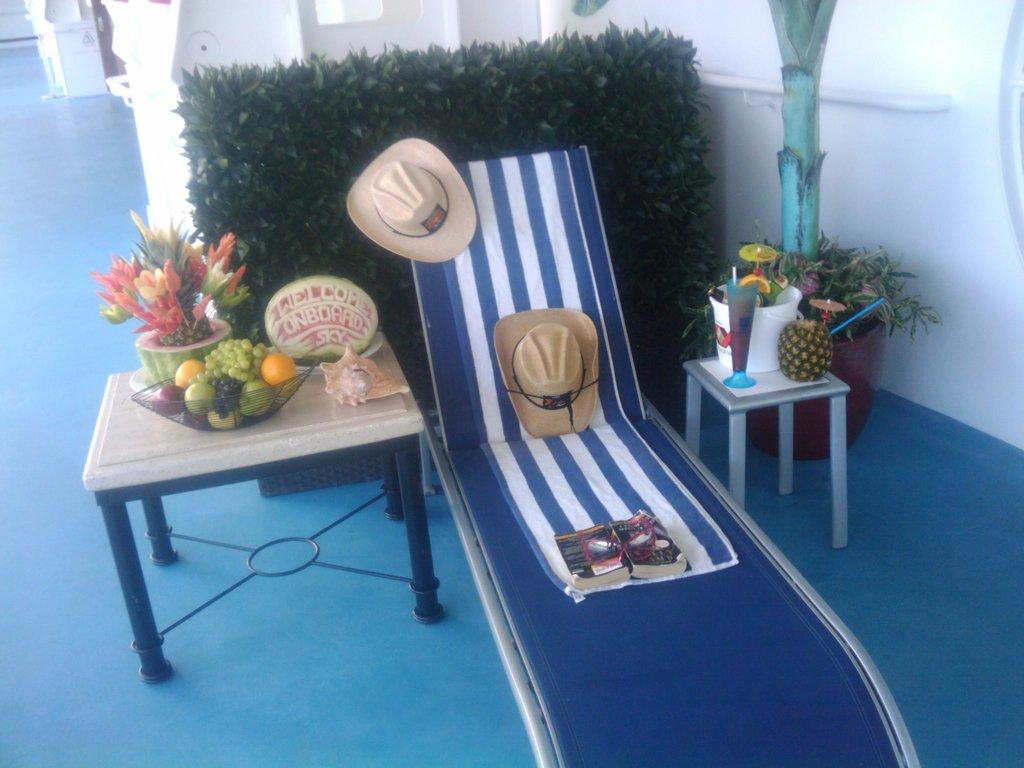What type of furniture is in the image? There is a bed, a table, and a chair in the image. Where are the fruits located in the image? Fruits are present on the bed and on the table. What else can be found on the bed besides fruits? There is a book and two hats on the bed. What type of bean is being used to fuel the industry in the image? There is no mention of beans or an industry in the image; it features a bed, table, chair, fruits, a book, and two hats. 